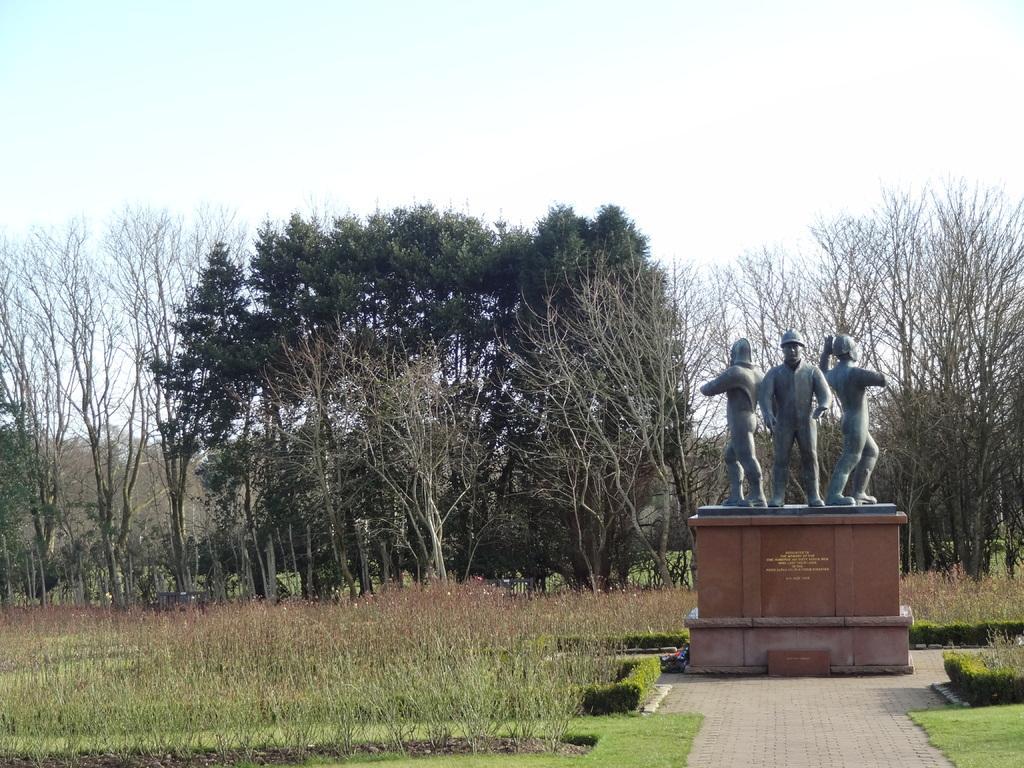Could you give a brief overview of what you see in this image? In this image we can see trees, plants, grass, statue and sky. 